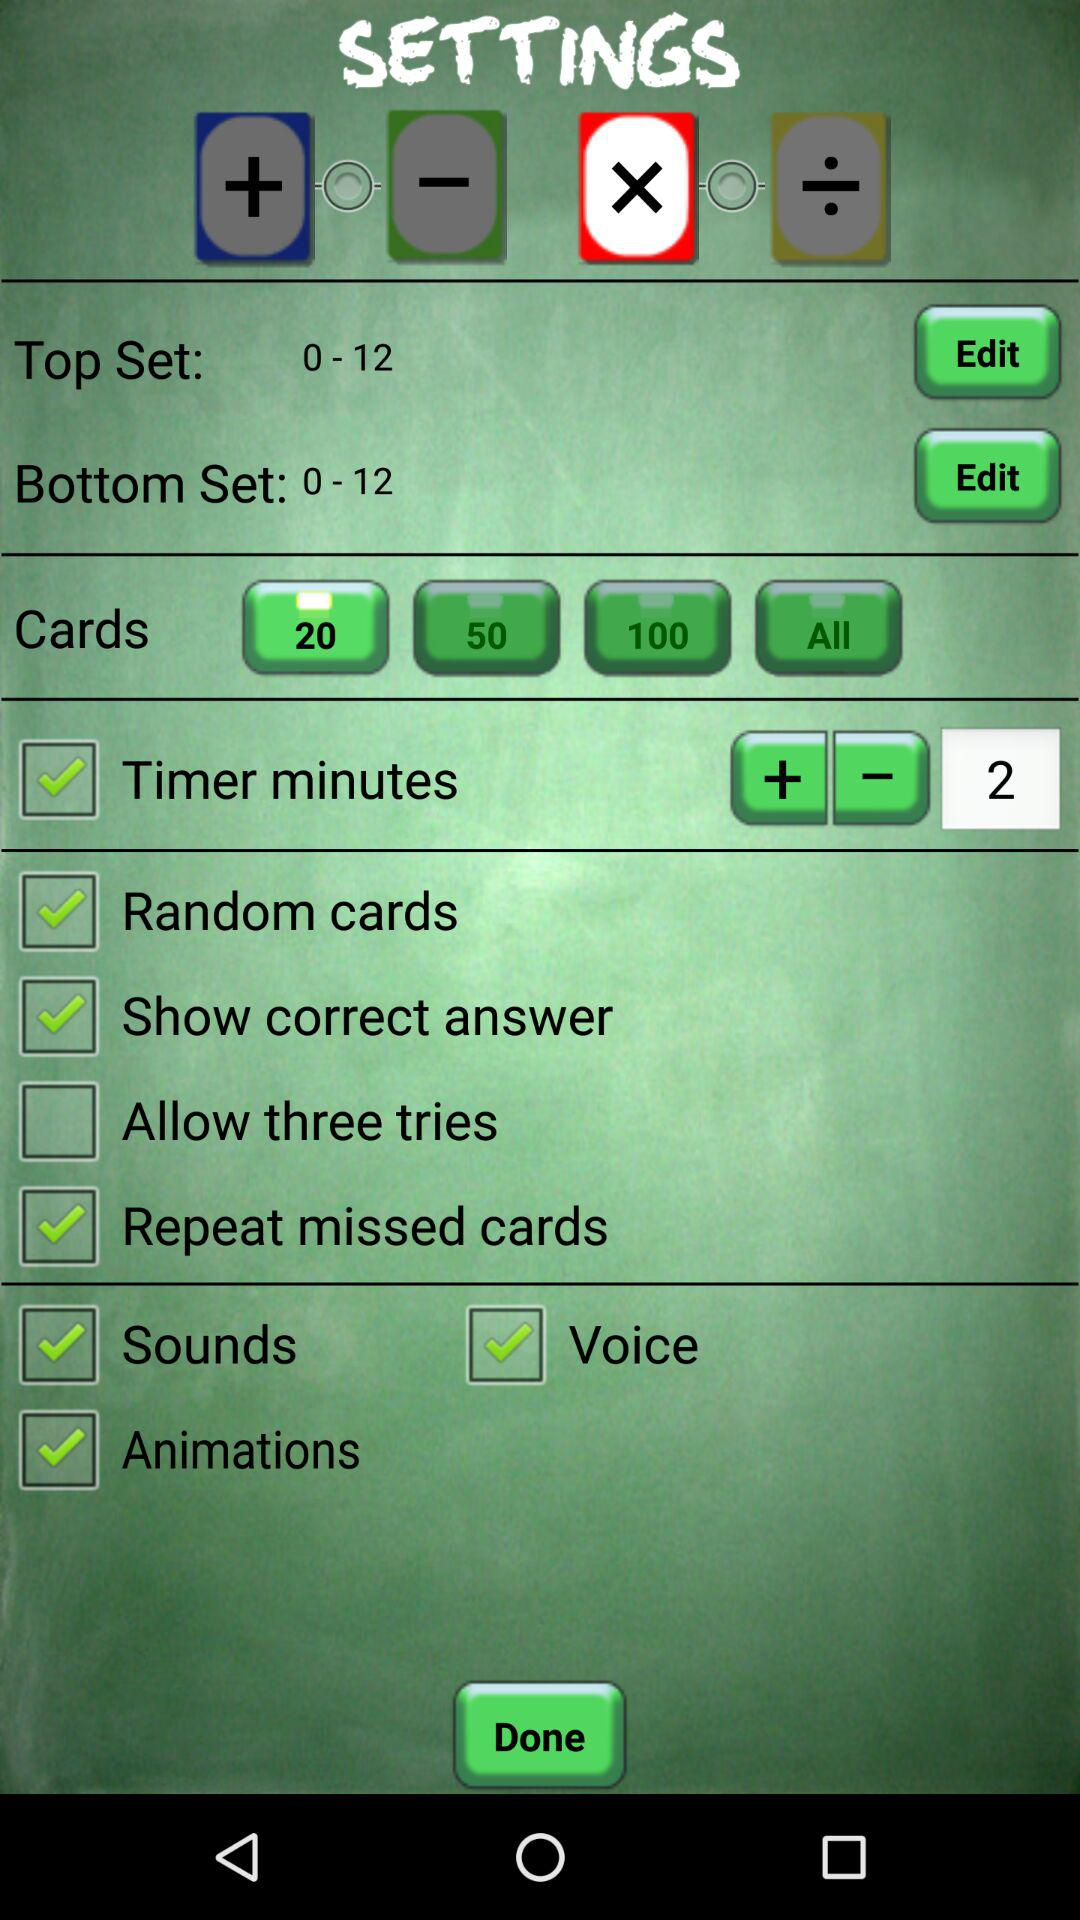What set of numbers is in the top set? The set numbers are 0-12. 